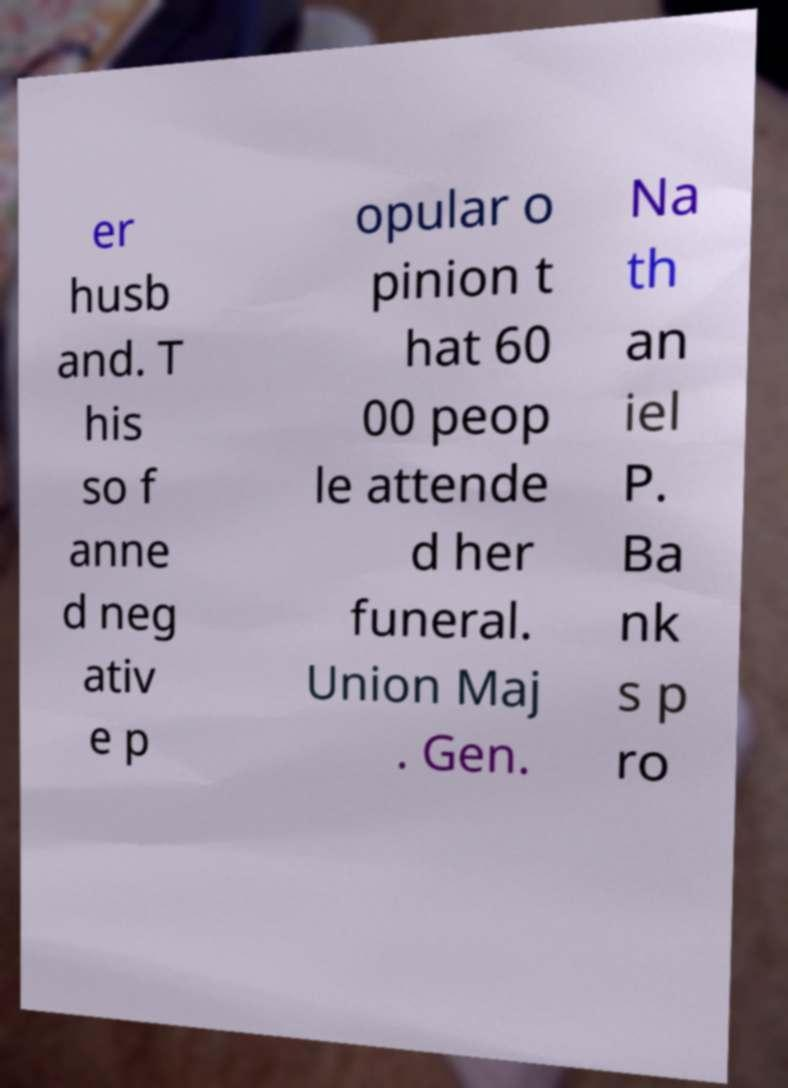Can you read and provide the text displayed in the image?This photo seems to have some interesting text. Can you extract and type it out for me? er husb and. T his so f anne d neg ativ e p opular o pinion t hat 60 00 peop le attende d her funeral. Union Maj . Gen. Na th an iel P. Ba nk s p ro 